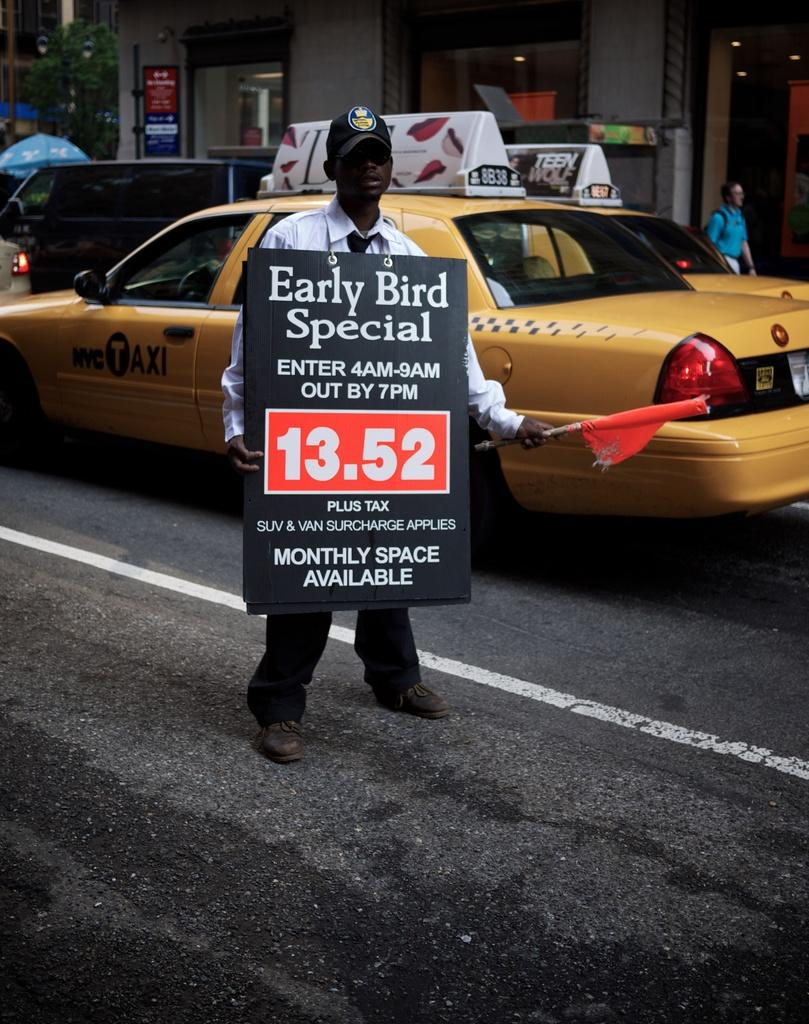<image>
Render a clear and concise summary of the photo. A man wears an advertisement for an early bird special for 13.52. 